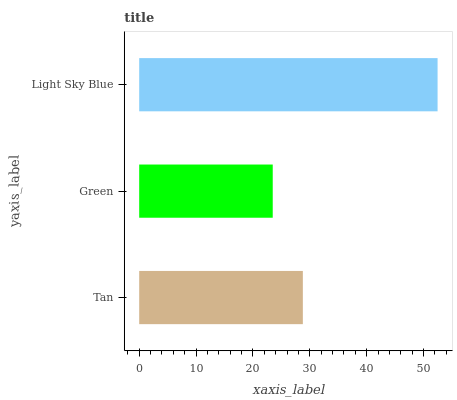Is Green the minimum?
Answer yes or no. Yes. Is Light Sky Blue the maximum?
Answer yes or no. Yes. Is Light Sky Blue the minimum?
Answer yes or no. No. Is Green the maximum?
Answer yes or no. No. Is Light Sky Blue greater than Green?
Answer yes or no. Yes. Is Green less than Light Sky Blue?
Answer yes or no. Yes. Is Green greater than Light Sky Blue?
Answer yes or no. No. Is Light Sky Blue less than Green?
Answer yes or no. No. Is Tan the high median?
Answer yes or no. Yes. Is Tan the low median?
Answer yes or no. Yes. Is Green the high median?
Answer yes or no. No. Is Green the low median?
Answer yes or no. No. 